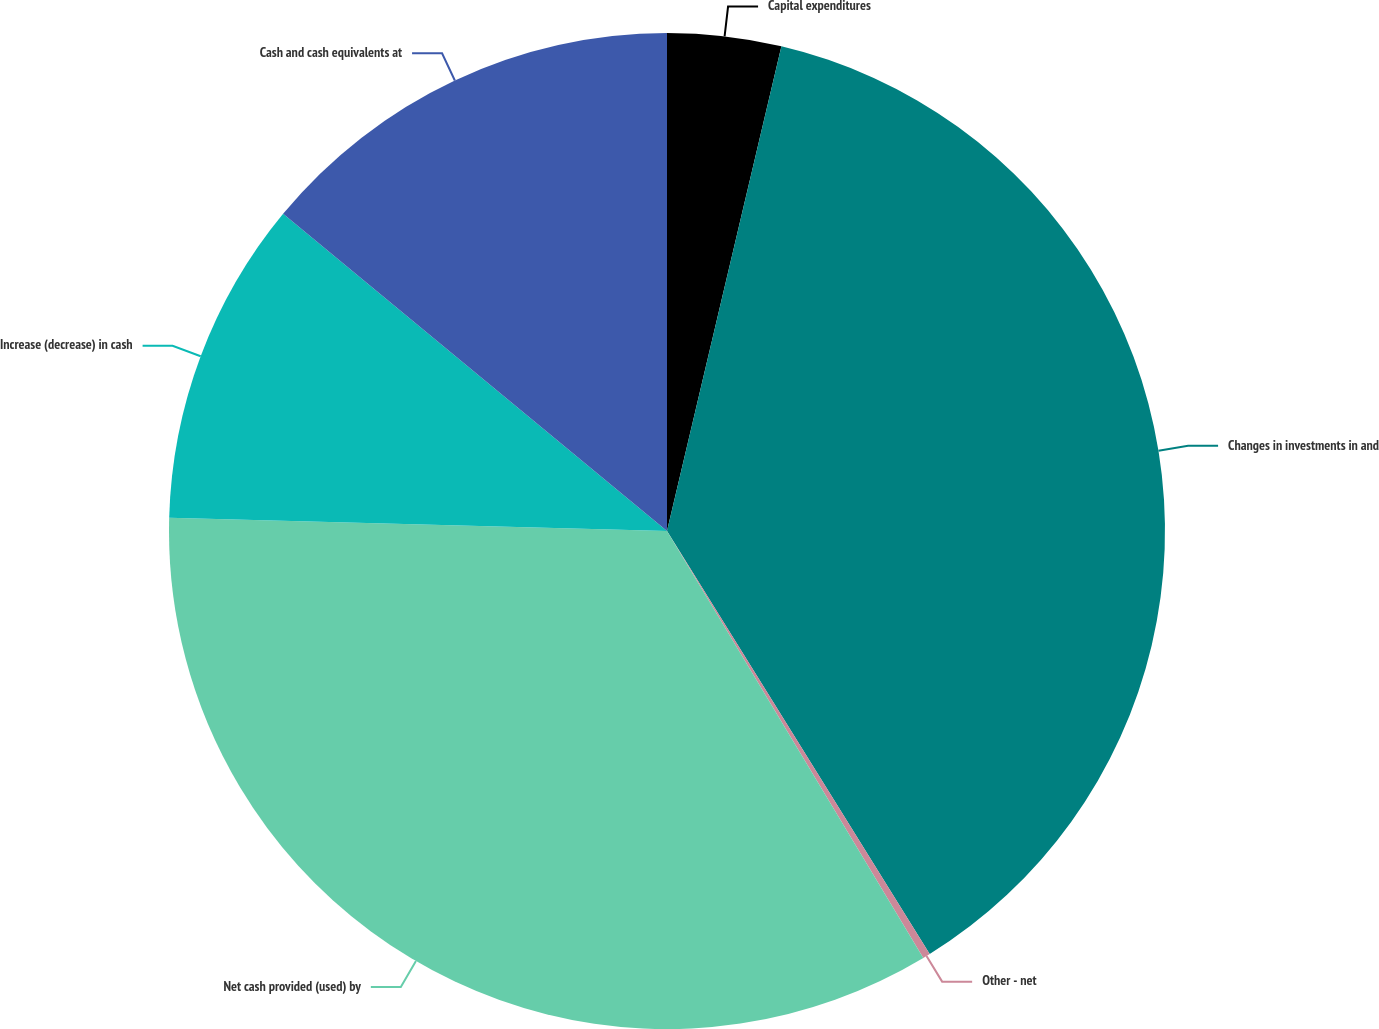Convert chart to OTSL. <chart><loc_0><loc_0><loc_500><loc_500><pie_chart><fcel>Capital expenditures<fcel>Changes in investments in and<fcel>Other - net<fcel>Net cash provided (used) by<fcel>Increase (decrease) in cash<fcel>Cash and cash equivalents at<nl><fcel>3.69%<fcel>37.47%<fcel>0.24%<fcel>34.03%<fcel>10.57%<fcel>14.01%<nl></chart> 